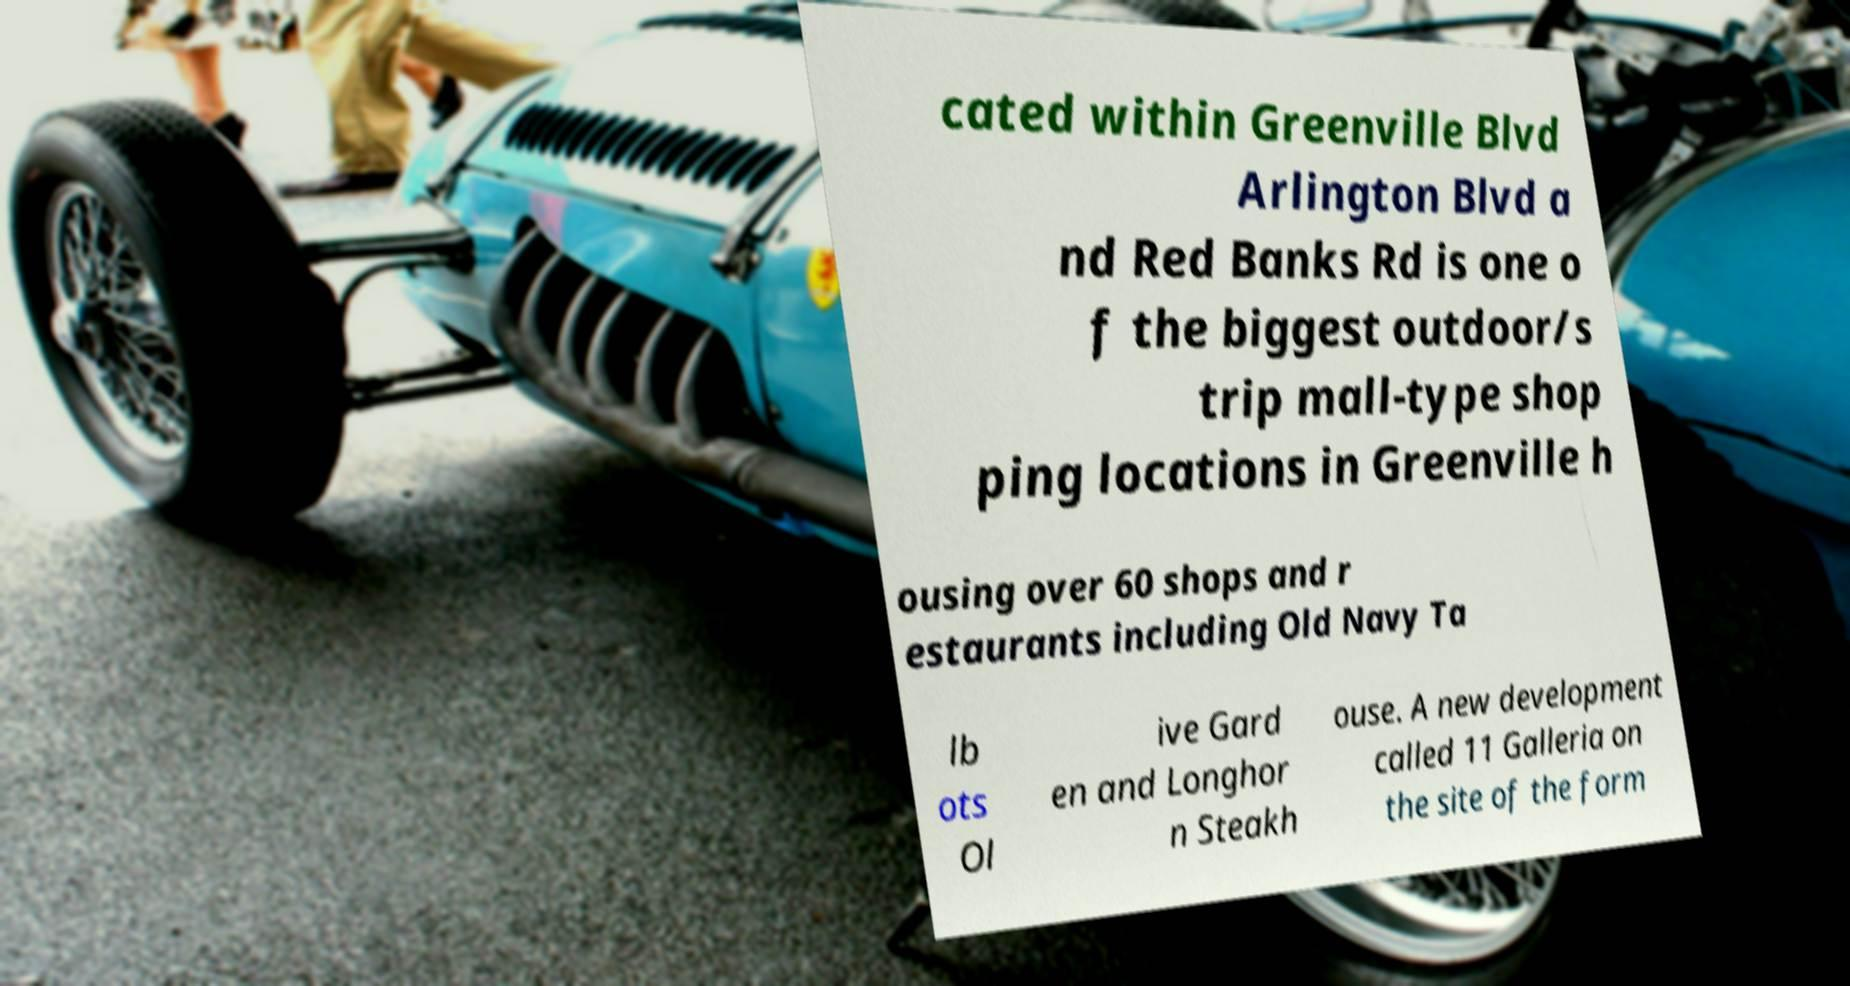There's text embedded in this image that I need extracted. Can you transcribe it verbatim? cated within Greenville Blvd Arlington Blvd a nd Red Banks Rd is one o f the biggest outdoor/s trip mall-type shop ping locations in Greenville h ousing over 60 shops and r estaurants including Old Navy Ta lb ots Ol ive Gard en and Longhor n Steakh ouse. A new development called 11 Galleria on the site of the form 